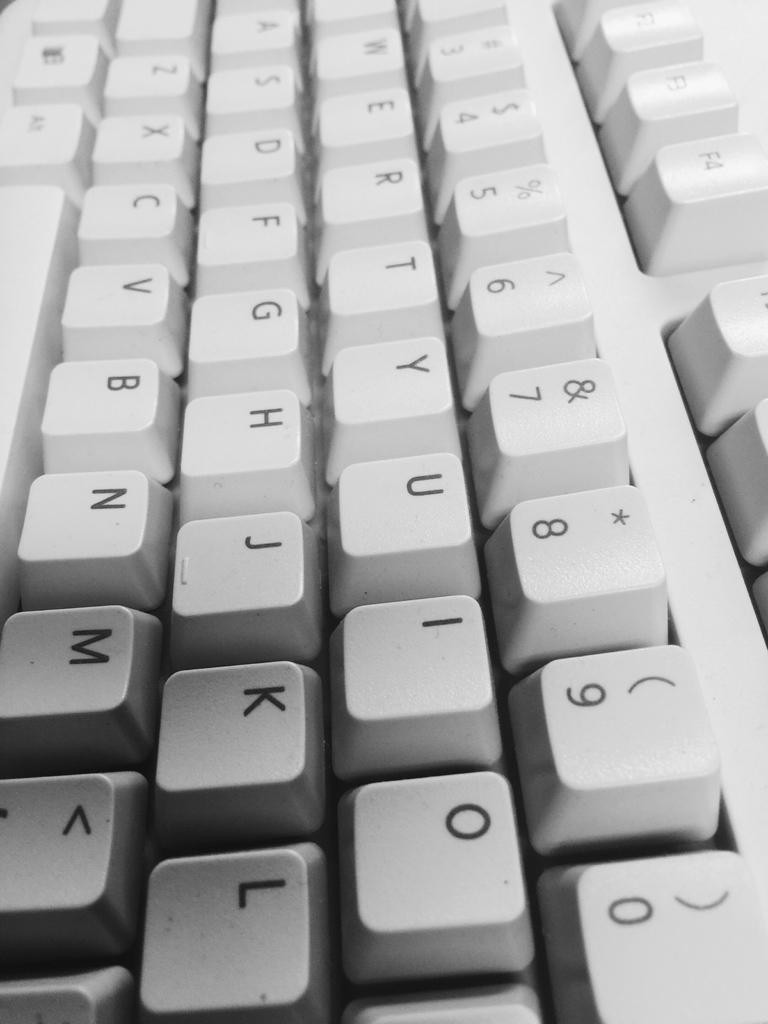<image>
Provide a brief description of the given image. A close up of a keyboard showing all the numbers from 3 to 9 then 0. 